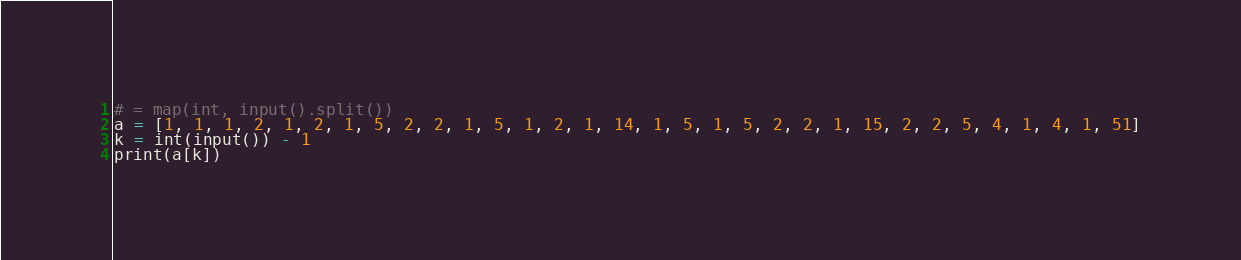Convert code to text. <code><loc_0><loc_0><loc_500><loc_500><_Python_># = map(int, input().split())
a = [1, 1, 1, 2, 1, 2, 1, 5, 2, 2, 1, 5, 1, 2, 1, 14, 1, 5, 1, 5, 2, 2, 1, 15, 2, 2, 5, 4, 1, 4, 1, 51]
k = int(input()) - 1
print(a[k])
</code> 